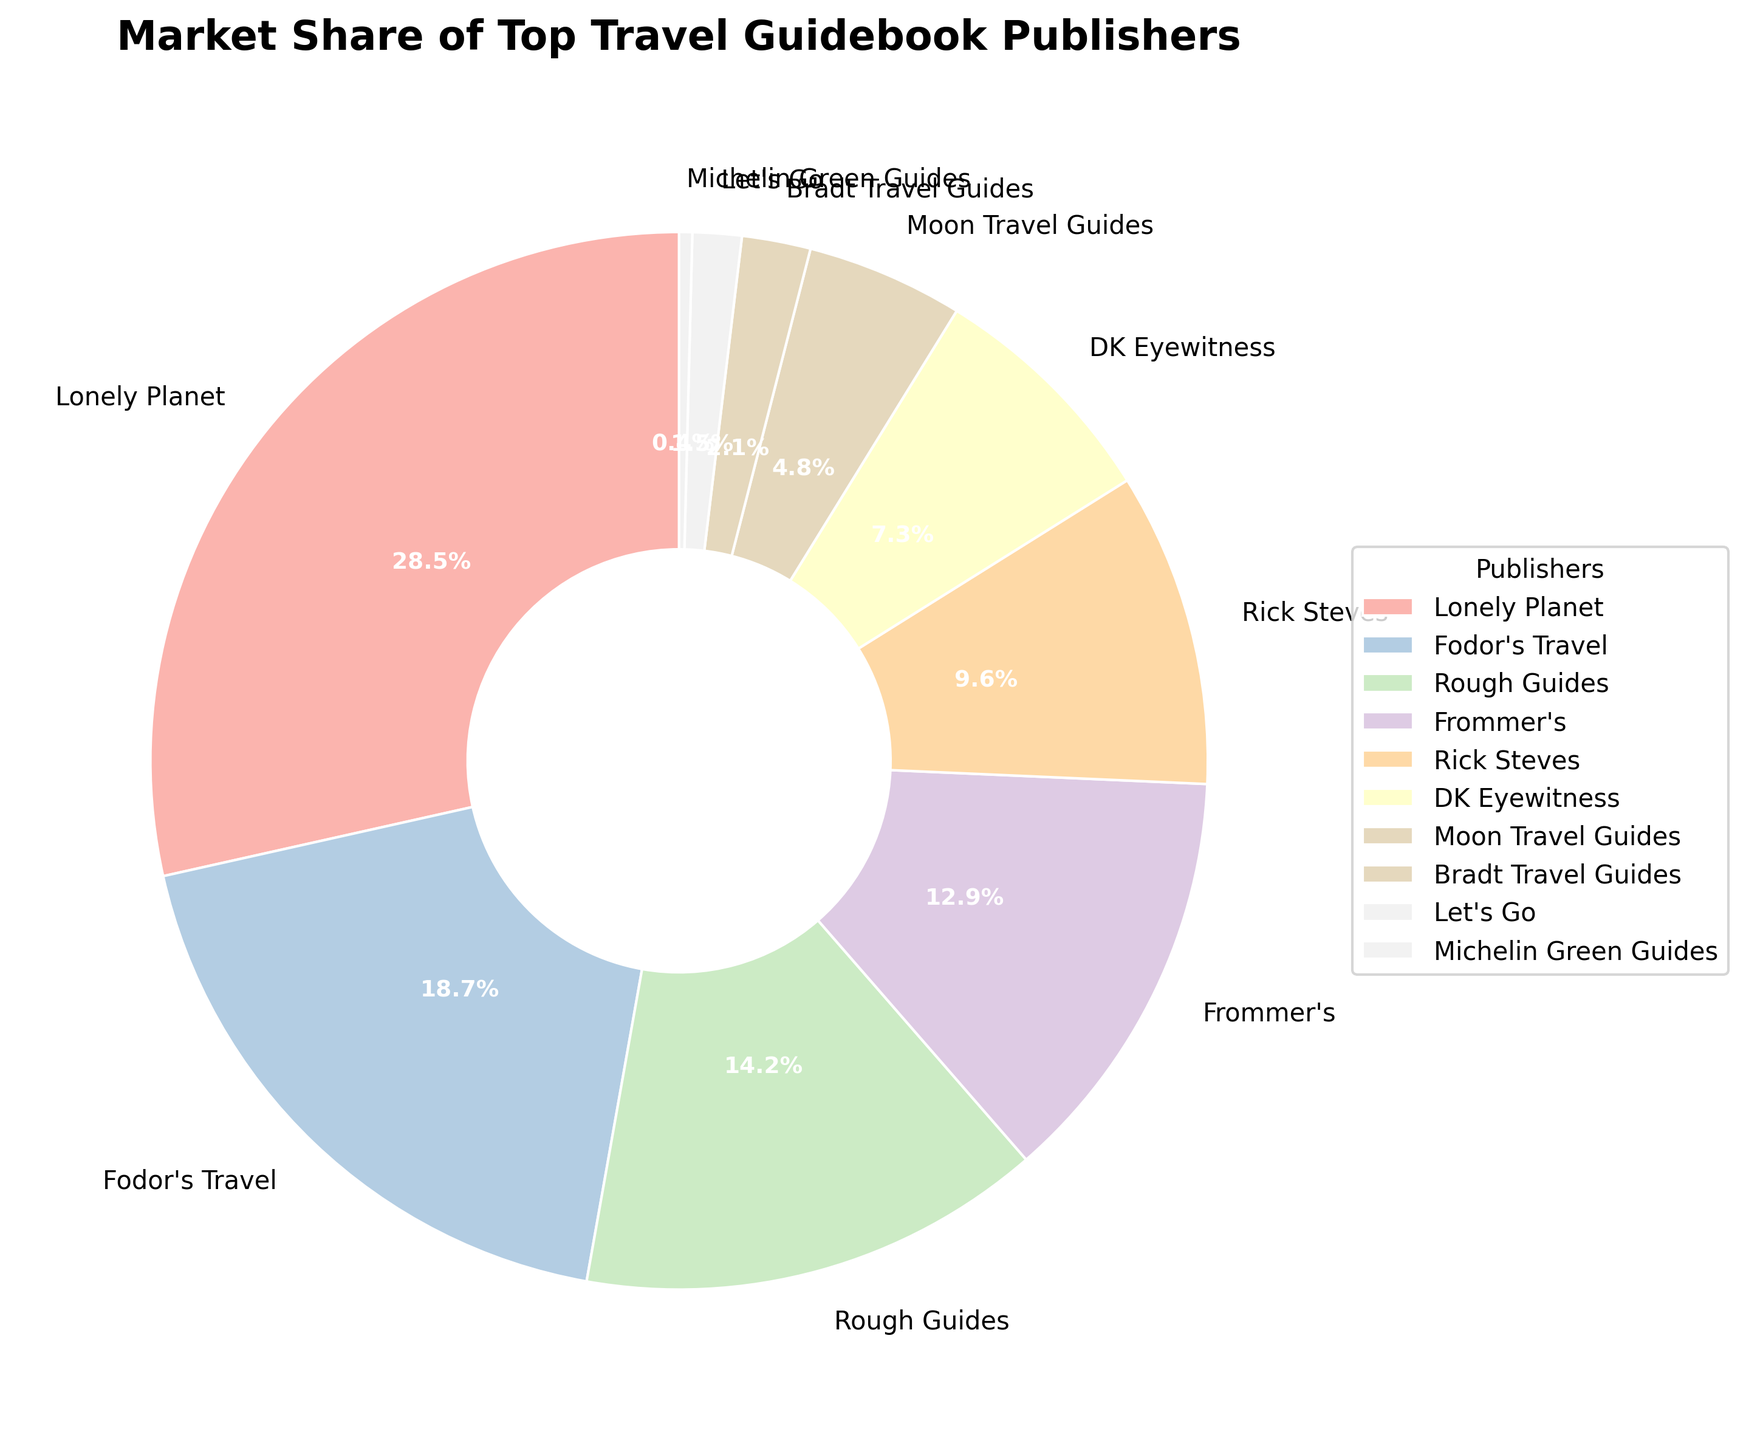What is the market share percentage of Lonely Planet? Look at the section labeled "Lonely Planet" on the pie chart, which shows the market share percentage.
Answer: 28.5% Which publisher has the smallest market share, and what is it? Identify the smallest segment in the pie chart, which is labeled "Michelin Green Guides", and check the percentage.
Answer: Michelin Green Guides, 0.4% Which two publishers combined have a market share greater than 40%? Look for the individual publishers' market shares and sum them up. Lonely Planet has 28.5% and Fodor's Travel has 18.7%. Combined, 28.5% + 18.7% = 47.2%, which is greater than 40%.
Answer: Lonely Planet and Fodor's Travel How many publishers have a market share greater than 10%? Identify and count the segments in the pie chart with market shares above 10%. These are Lonely Planet, Fodor's Travel, Rough Guides, and Frommer's.
Answer: 4 Which publisher has a higher market share: Rough Guides or Rick Steves? Compare the market share percentages of "Rough Guides" and "Rick Steves" on the pie chart. Rough Guides has 14.2% while Rick Steves has 9.6%.
Answer: Rough Guides What is the total market share of publishers with less than 5% market share each? Sum the market shares of Moon Travel Guides, Bradt Travel Guides, Let's Go, and Michelin Green Guides (4.8% + 2.1% + 1.5% + 0.4%).
Answer: 8.8% Which segment is colored in the lightest shade, and what is that publisher's market share? Locate the lightest-colored segment on the pie chart, labeled "Michelin Green Guides". The market share is 0.4%.
Answer: Michelin Green Guides, 0.4% Between DK Eyewitness and Moon Travel Guides, which has a lower market share and by how much? Compare the market share percentages of DK Eyewitness (7.3%) and Moon Travel Guides (4.8%). The difference is calculated as 7.3% - 4.8%.
Answer: Moon Travel Guides by 2.5% If you combine the market shares of Frommer’s and DK Eyewitness, what percentage of the market does that represent? Add the market shares of Frommer's (12.9%) and DK Eyewitness (7.3%). The total is 12.9% + 7.3%.
Answer: 20.2% What is the difference in market share between the top publisher and the publisher with the second highest market share? Subtract the market share of Fodor's Travel (second highest at 18.7%) from Lonely Planet (highest at 28.5%).
Answer: 9.8% 